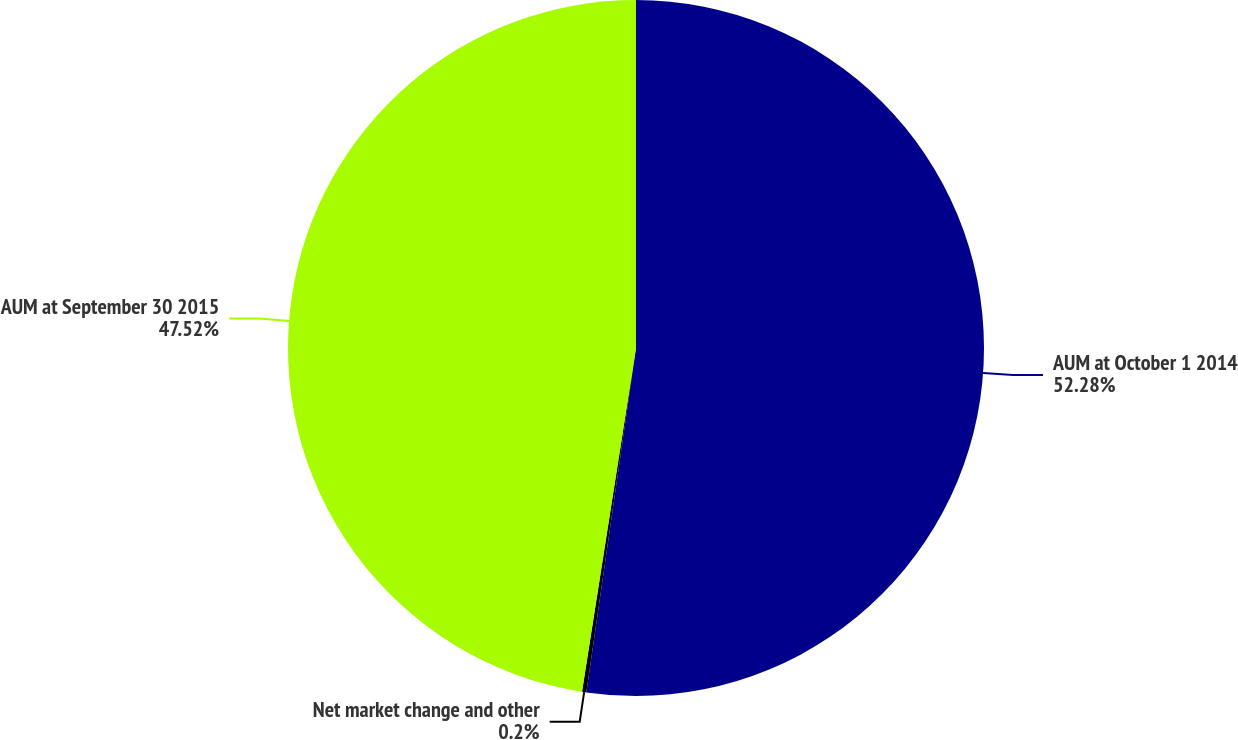<chart> <loc_0><loc_0><loc_500><loc_500><pie_chart><fcel>AUM at October 1 2014<fcel>Net market change and other<fcel>AUM at September 30 2015<nl><fcel>52.28%<fcel>0.2%<fcel>47.52%<nl></chart> 